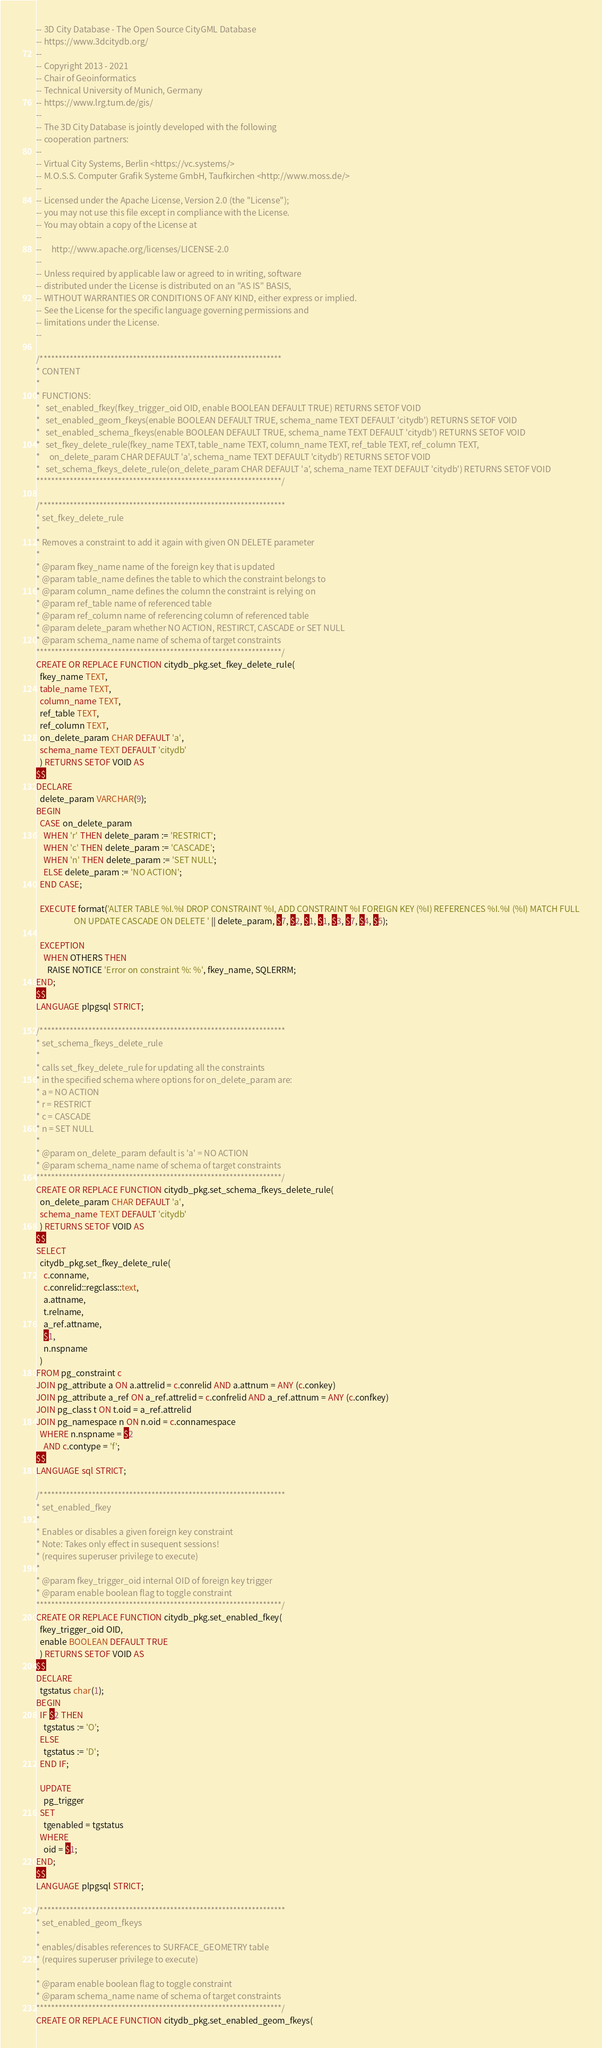<code> <loc_0><loc_0><loc_500><loc_500><_SQL_>-- 3D City Database - The Open Source CityGML Database
-- https://www.3dcitydb.org/
--
-- Copyright 2013 - 2021
-- Chair of Geoinformatics
-- Technical University of Munich, Germany
-- https://www.lrg.tum.de/gis/
--
-- The 3D City Database is jointly developed with the following
-- cooperation partners:
--
-- Virtual City Systems, Berlin <https://vc.systems/>
-- M.O.S.S. Computer Grafik Systeme GmbH, Taufkirchen <http://www.moss.de/>
--
-- Licensed under the Apache License, Version 2.0 (the "License");
-- you may not use this file except in compliance with the License.
-- You may obtain a copy of the License at
--
--     http://www.apache.org/licenses/LICENSE-2.0
--
-- Unless required by applicable law or agreed to in writing, software
-- distributed under the License is distributed on an "AS IS" BASIS,
-- WITHOUT WARRANTIES OR CONDITIONS OF ANY KIND, either express or implied.
-- See the License for the specific language governing permissions and
-- limitations under the License.
--

/*****************************************************************
* CONTENT
*
* FUNCTIONS:
*   set_enabled_fkey(fkey_trigger_oid OID, enable BOOLEAN DEFAULT TRUE) RETURNS SETOF VOID
*   set_enabled_geom_fkeys(enable BOOLEAN DEFAULT TRUE, schema_name TEXT DEFAULT 'citydb') RETURNS SETOF VOID
*   set_enabled_schema_fkeys(enable BOOLEAN DEFAULT TRUE, schema_name TEXT DEFAULT 'citydb') RETURNS SETOF VOID
*   set_fkey_delete_rule(fkey_name TEXT, table_name TEXT, column_name TEXT, ref_table TEXT, ref_column TEXT, 
*     on_delete_param CHAR DEFAULT 'a', schema_name TEXT DEFAULT 'citydb') RETURNS SETOF VOID
*   set_schema_fkeys_delete_rule(on_delete_param CHAR DEFAULT 'a', schema_name TEXT DEFAULT 'citydb') RETURNS SETOF VOID
******************************************************************/

/******************************************************************
* set_fkey_delete_rule
*
* Removes a constraint to add it again with given ON DELETE parameter
*
* @param fkey_name name of the foreign key that is updated 
* @param table_name defines the table to which the constraint belongs to
* @param column_name defines the column the constraint is relying on
* @param ref_table name of referenced table
* @param ref_column name of referencing column of referenced table
* @param delete_param whether NO ACTION, RESTIRCT, CASCADE or SET NULL
* @param schema_name name of schema of target constraints
******************************************************************/
CREATE OR REPLACE FUNCTION citydb_pkg.set_fkey_delete_rule(
  fkey_name TEXT,
  table_name TEXT,
  column_name TEXT,
  ref_table TEXT,
  ref_column TEXT,
  on_delete_param CHAR DEFAULT 'a',
  schema_name TEXT DEFAULT 'citydb'
  ) RETURNS SETOF VOID AS 
$$
DECLARE
  delete_param VARCHAR(9);
BEGIN
  CASE on_delete_param
    WHEN 'r' THEN delete_param := 'RESTRICT';
    WHEN 'c' THEN delete_param := 'CASCADE';
    WHEN 'n' THEN delete_param := 'SET NULL';
    ELSE delete_param := 'NO ACTION';
  END CASE;

  EXECUTE format('ALTER TABLE %I.%I DROP CONSTRAINT %I, ADD CONSTRAINT %I FOREIGN KEY (%I) REFERENCES %I.%I (%I) MATCH FULL
                    ON UPDATE CASCADE ON DELETE ' || delete_param, $7, $2, $1, $1, $3, $7, $4, $5);

  EXCEPTION
    WHEN OTHERS THEN
      RAISE NOTICE 'Error on constraint %: %', fkey_name, SQLERRM;
END;
$$
LANGUAGE plpgsql STRICT;

/******************************************************************
* set_schema_fkeys_delete_rule
*
* calls set_fkey_delete_rule for updating all the constraints
* in the specified schema where options for on_delete_param are:
* a = NO ACTION
* r = RESTRICT
* c = CASCADE
* n = SET NULL
*
* @param on_delete_param default is 'a' = NO ACTION
* @param schema_name name of schema of target constraints
******************************************************************/
CREATE OR REPLACE FUNCTION citydb_pkg.set_schema_fkeys_delete_rule(
  on_delete_param CHAR DEFAULT 'a',
  schema_name TEXT DEFAULT 'citydb'
  ) RETURNS SETOF VOID AS 
$$
SELECT
  citydb_pkg.set_fkey_delete_rule(
    c.conname,
    c.conrelid::regclass::text,
    a.attname,
    t.relname,
    a_ref.attname,
    $1,
    n.nspname
  )
FROM pg_constraint c
JOIN pg_attribute a ON a.attrelid = c.conrelid AND a.attnum = ANY (c.conkey)
JOIN pg_attribute a_ref ON a_ref.attrelid = c.confrelid AND a_ref.attnum = ANY (c.confkey)
JOIN pg_class t ON t.oid = a_ref.attrelid
JOIN pg_namespace n ON n.oid = c.connamespace
  WHERE n.nspname = $2
    AND c.contype = 'f';
$$
LANGUAGE sql STRICT;

/******************************************************************
* set_enabled_fkey
*
* Enables or disables a given foreign key constraint
* Note: Takes only effect in susequent sessions!
* (requires superuser privilege to execute)
*
* @param fkey_trigger_oid internal OID of foreign key trigger
* @param enable boolean flag to toggle constraint
******************************************************************/
CREATE OR REPLACE FUNCTION citydb_pkg.set_enabled_fkey(
  fkey_trigger_oid OID,
  enable BOOLEAN DEFAULT TRUE
  ) RETURNS SETOF VOID AS
$$
DECLARE
  tgstatus char(1);
BEGIN
  IF $2 THEN
    tgstatus := 'O';
  ELSE
    tgstatus := 'D';
  END IF;

  UPDATE
    pg_trigger
  SET
    tgenabled = tgstatus
  WHERE
    oid = $1;
END;
$$
LANGUAGE plpgsql STRICT;

/******************************************************************
* set_enabled_geom_fkeys
*
* enables/disables references to SURFACE_GEOMETRY table
* (requires superuser privilege to execute)
*
* @param enable boolean flag to toggle constraint
* @param schema_name name of schema of target constraints
******************************************************************/
CREATE OR REPLACE FUNCTION citydb_pkg.set_enabled_geom_fkeys(</code> 